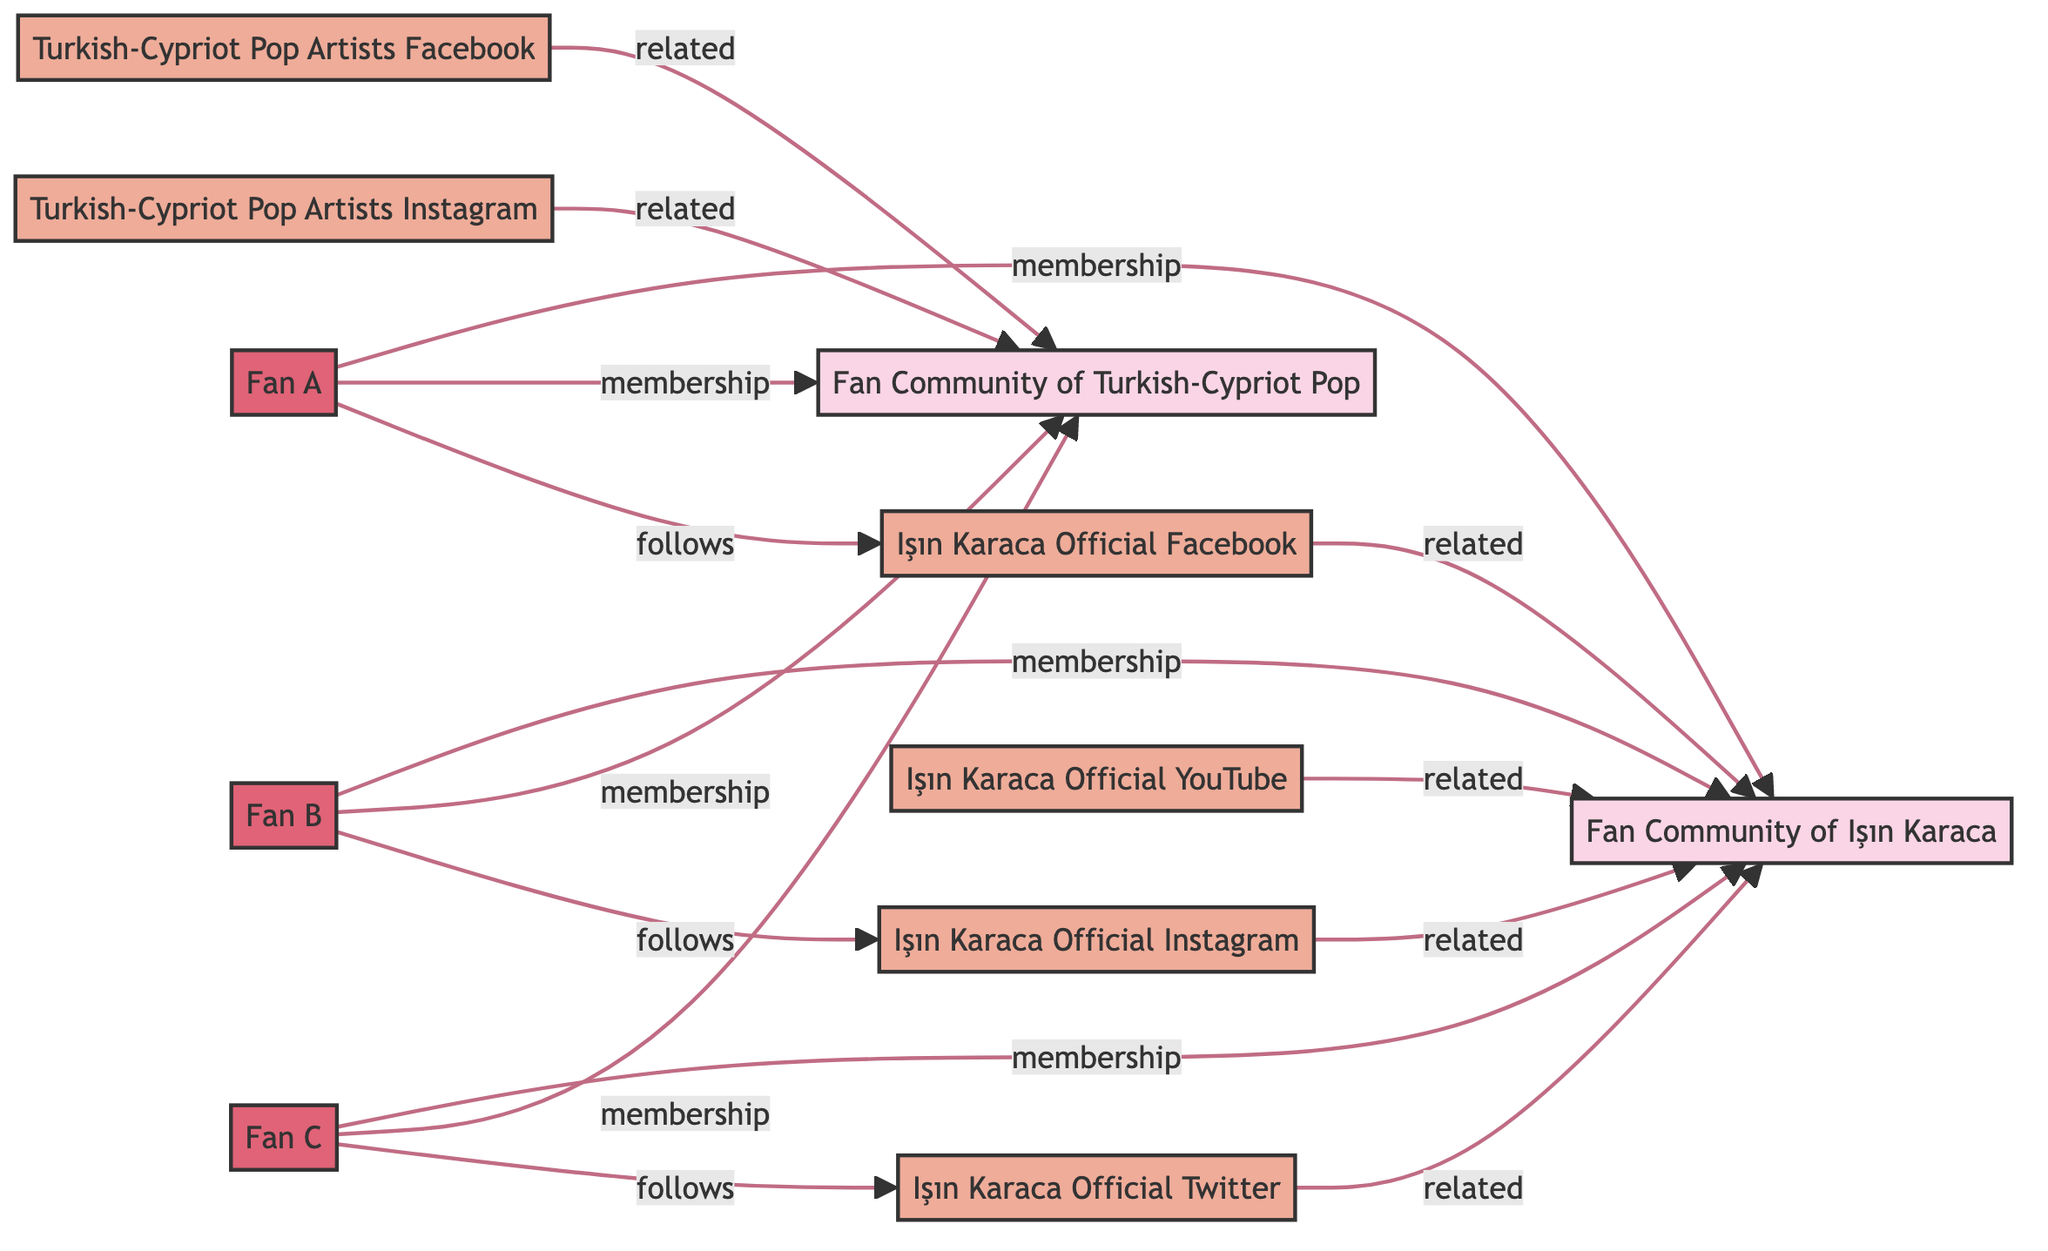What are the nodes representing social media platforms? The social media nodes in the diagram include Işın Karaca Official Facebook, Işın Karaca Official Instagram, Işın Karaca Official Twitter, Işın Karaca Official YouTube, Turkish-Cypriot Pop Artists Facebook, and Turkish-Cypriot Pop Artists Instagram. These nodes are linked to either the Fan Community of Işın Karaca or the Fan Community of Turkish-Cypriot Pop, indicating their role in connecting fans online.
Answer: Işın Karaca Official Facebook, Işın Karaca Official Instagram, Işın Karaca Official Twitter, Işın Karaca Official YouTube, Turkish-Cypriot Pop Artists Facebook, Turkish-Cypriot Pop Artists Instagram How many fans are members of the Fan Community of Işın Karaca? The diagram shows three links from individuals (Fan A, Fan B, and Fan C) to the Fan Community of Işın Karaca, indicating that all three fans are members of this community. Membership is denoted by the type of relationship in the links.
Answer: 3 Which fan follows Işın Karaca Official Twitter? To find this information, we look at the connection from the fans to the social media platforms. The link from Fan C to Işın Karaca Official Twitter indicates that Fan C is the one who follows this social media account.
Answer: Fan C What type of relationships do fans have with the Turkish-Cypriot Pop Community? The diagram shows membership connections from Fan A, Fan B, and Fan C to the Fan Community of Turkish-Cypriot Pop. Thus, the type of relationship that fans have with this community is 'membership'.
Answer: membership Which fans are members of both fan communities? By reviewing the membership links, we see that Fan A, Fan B, and Fan C are all linked to both the Fan Community of Işın Karaca and the Fan Community of Turkish-Cypriot Pop. Therefore, all three fans are members of both communities.
Answer: Fan A, Fan B, Fan C How many social media platforms are related to the Fan Community of Işın Karaca? The diagram illustrates four social media nodes that share a 'related' relationship with the Fan Community of Işın Karaca. These are the official Facebook, Instagram, Twitter, and YouTube accounts of Işın Karaca.
Answer: 4 What is the relationship type between Işın Karaca Official Facebook and the Fan Community of Işın Karaca? The link between Işın Karaca Official Facebook and the Fan Community of Işın Karaca is labeled as 'related', indicating a connection but not a membership or direct following.
Answer: related Are there any fans that do not follow any social media platforms? The diagram shows that each fan (Fan A, Fan B, Fan C) has a following relationship with a social media platform. Therefore, there are no fans without any social media followings represented in this diagram.
Answer: No 